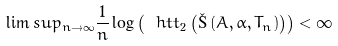<formula> <loc_0><loc_0><loc_500><loc_500>\lim s u p _ { n \to \infty } \frac { 1 } { n } \log \left ( \ h t t _ { 2 } \left ( \L \left ( A , \alpha , T _ { n } \right ) \right ) \right ) < \infty</formula> 